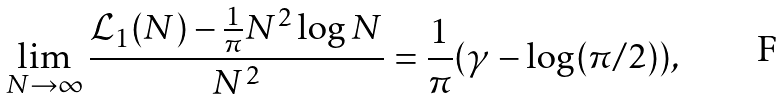<formula> <loc_0><loc_0><loc_500><loc_500>\lim _ { N \rightarrow \infty } \frac { \mathcal { L } _ { 1 } ( N ) - \frac { 1 } { \pi } N ^ { 2 } \log N } { N ^ { 2 } } = \frac { 1 } { \pi } ( \gamma - \log ( \pi / 2 ) ) ,</formula> 